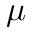<formula> <loc_0><loc_0><loc_500><loc_500>\mu</formula> 